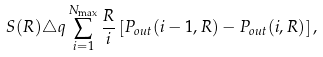<formula> <loc_0><loc_0><loc_500><loc_500>S ( R ) \triangle q \sum _ { i = 1 } ^ { N _ { \max } } \frac { R } { i } \left [ P _ { o u t } ( i - 1 , R ) - P _ { o u t } ( i , R ) \right ] ,</formula> 